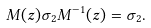<formula> <loc_0><loc_0><loc_500><loc_500>M ( z ) \sigma _ { 2 } M ^ { - 1 } ( z ) = \sigma _ { 2 } .</formula> 